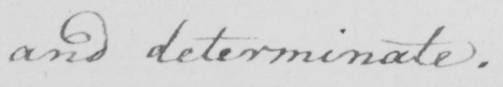Can you read and transcribe this handwriting? and determinate . 